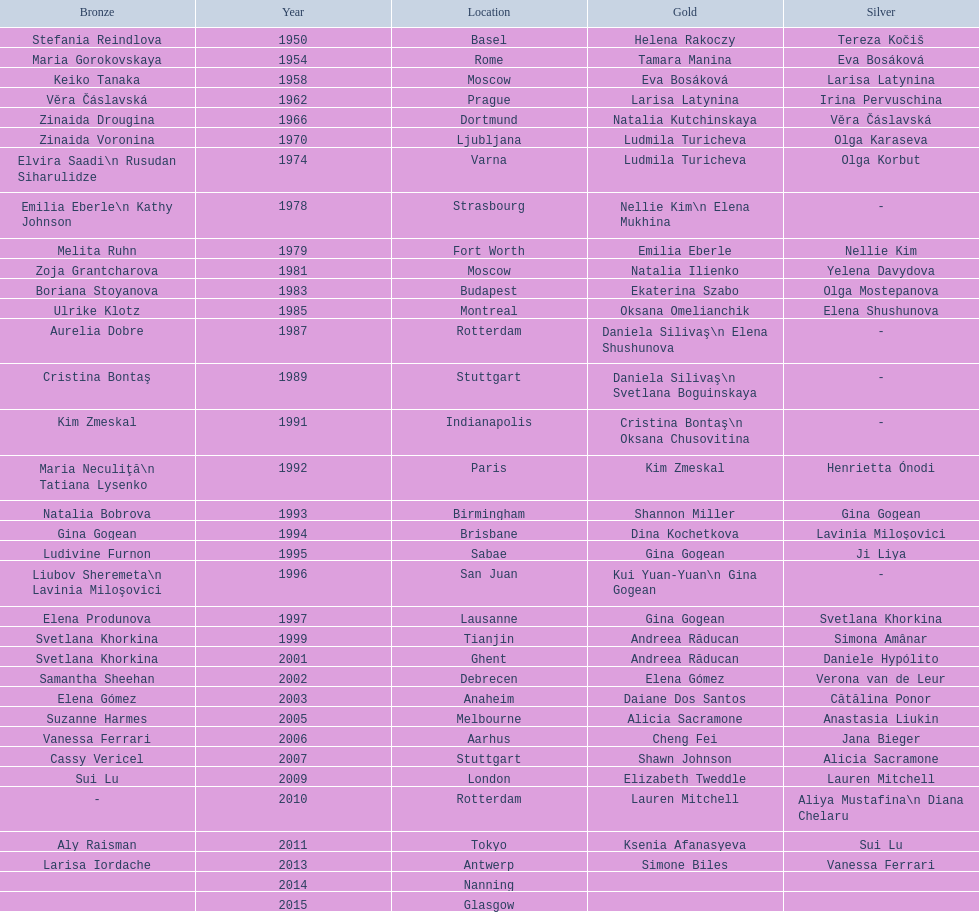Where were the championships held before the 1962 prague championships? Moscow. 